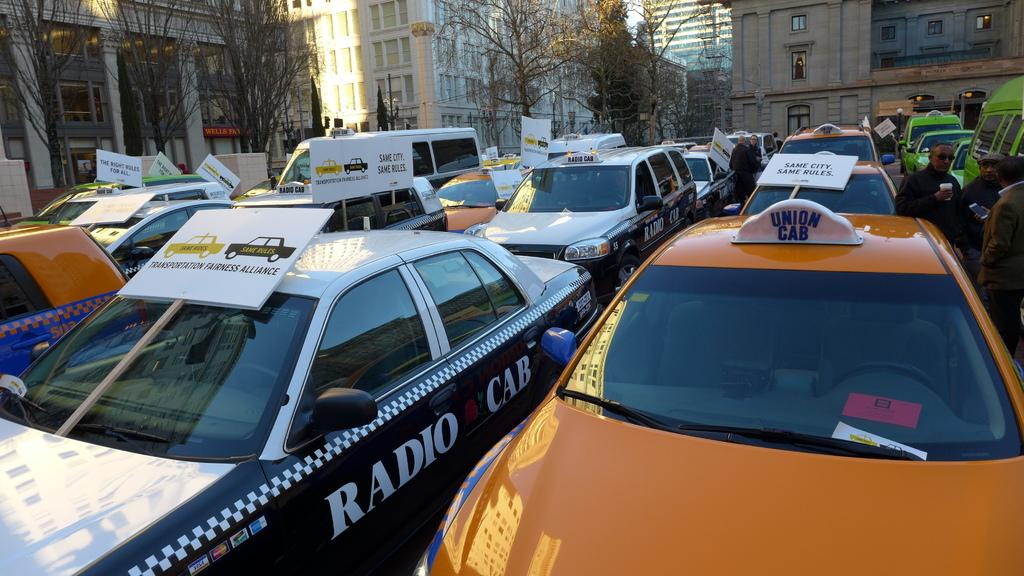<image>
Render a clear and concise summary of the photo. A Radio Cab in a lot holding lots of vehicles. 